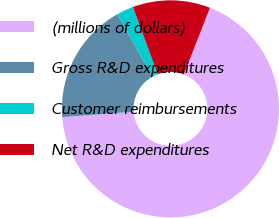<chart> <loc_0><loc_0><loc_500><loc_500><pie_chart><fcel>(millions of dollars)<fcel>Gross R&D expenditures<fcel>Customer reimbursements<fcel>Net R&D expenditures<nl><fcel>67.85%<fcel>18.09%<fcel>2.51%<fcel>11.55%<nl></chart> 